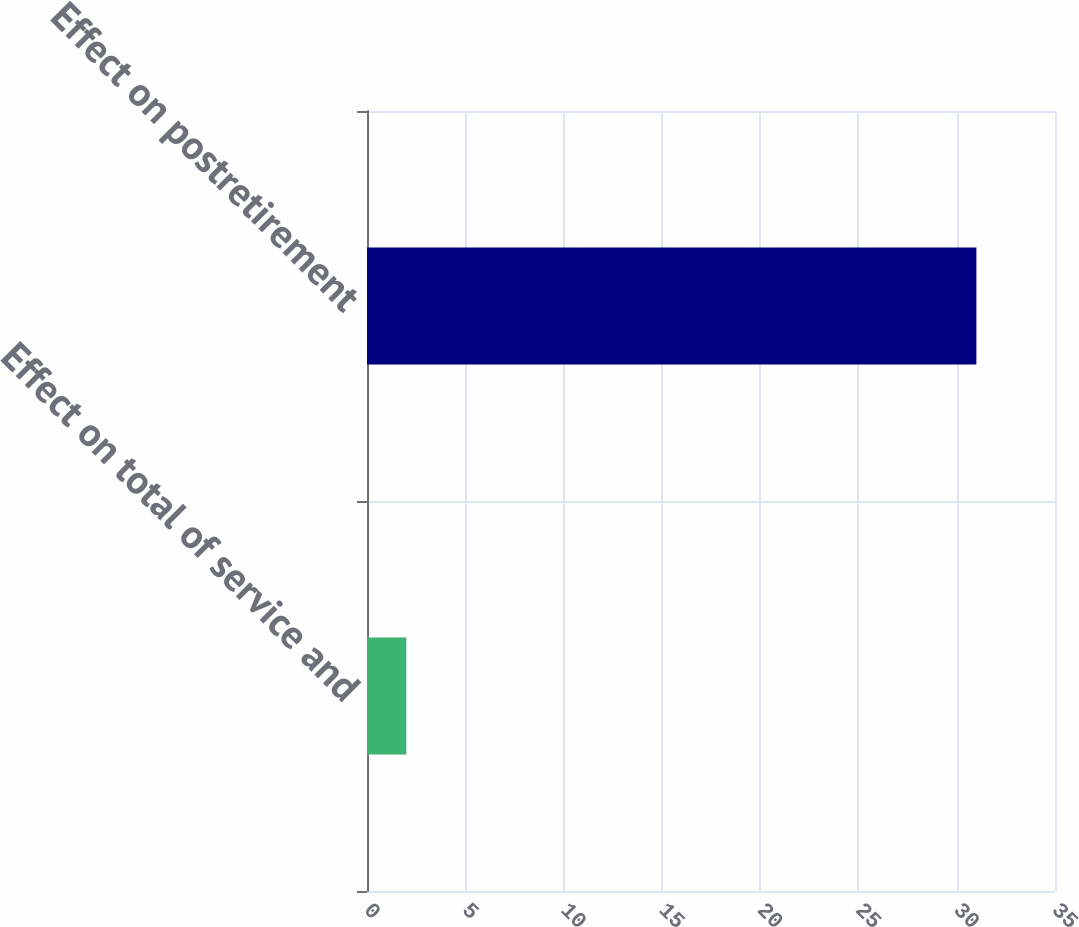Convert chart. <chart><loc_0><loc_0><loc_500><loc_500><bar_chart><fcel>Effect on total of service and<fcel>Effect on postretirement<nl><fcel>2<fcel>31<nl></chart> 